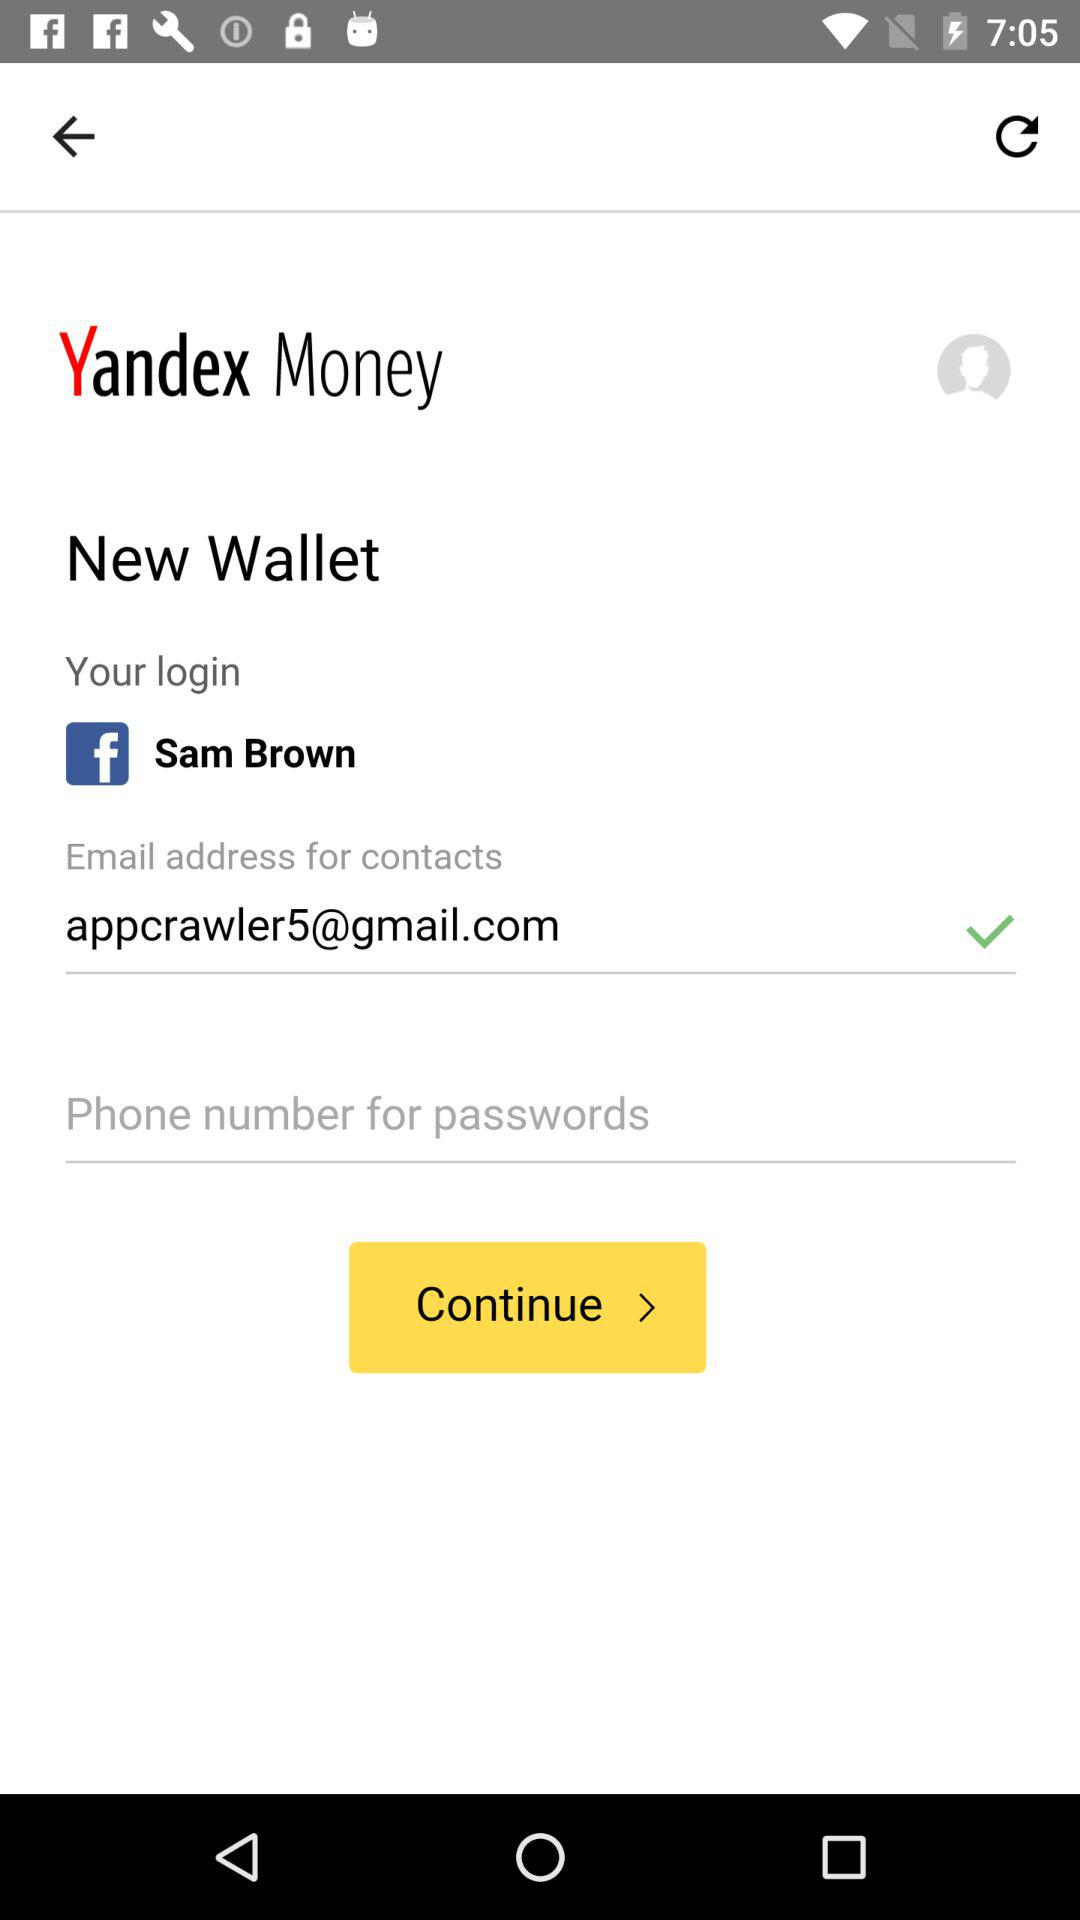What email address is used to log in? The used email address is appcrawler5@gmail.com. 